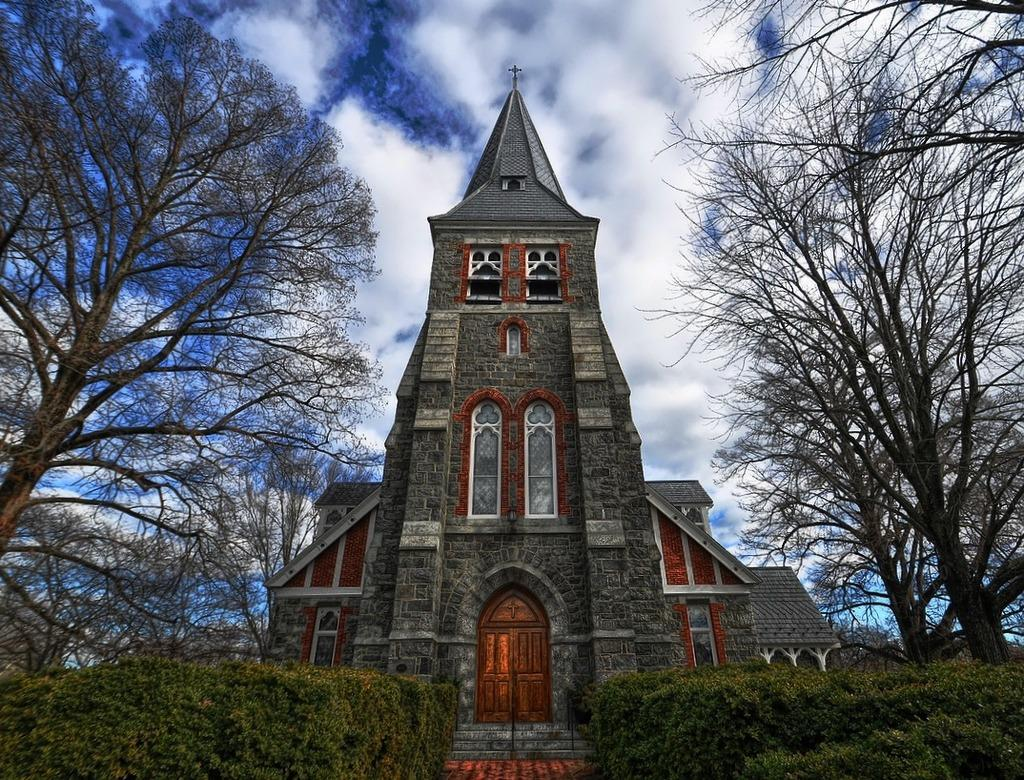What type of building is in the picture? There is a church building in the picture. What feature of the church building is mentioned in the facts? The church building has a door. What type of vegetation is present near the church building? There are bushes and trees on the sides of the church building. What can be seen in the background of the picture? The sky is visible behind the church building, and clouds are present in the sky. What type of hope can be seen growing on the leg of the church building in the image? There is no mention of hope or a leg in the provided facts, and therefore no such detail can be observed in the image. 